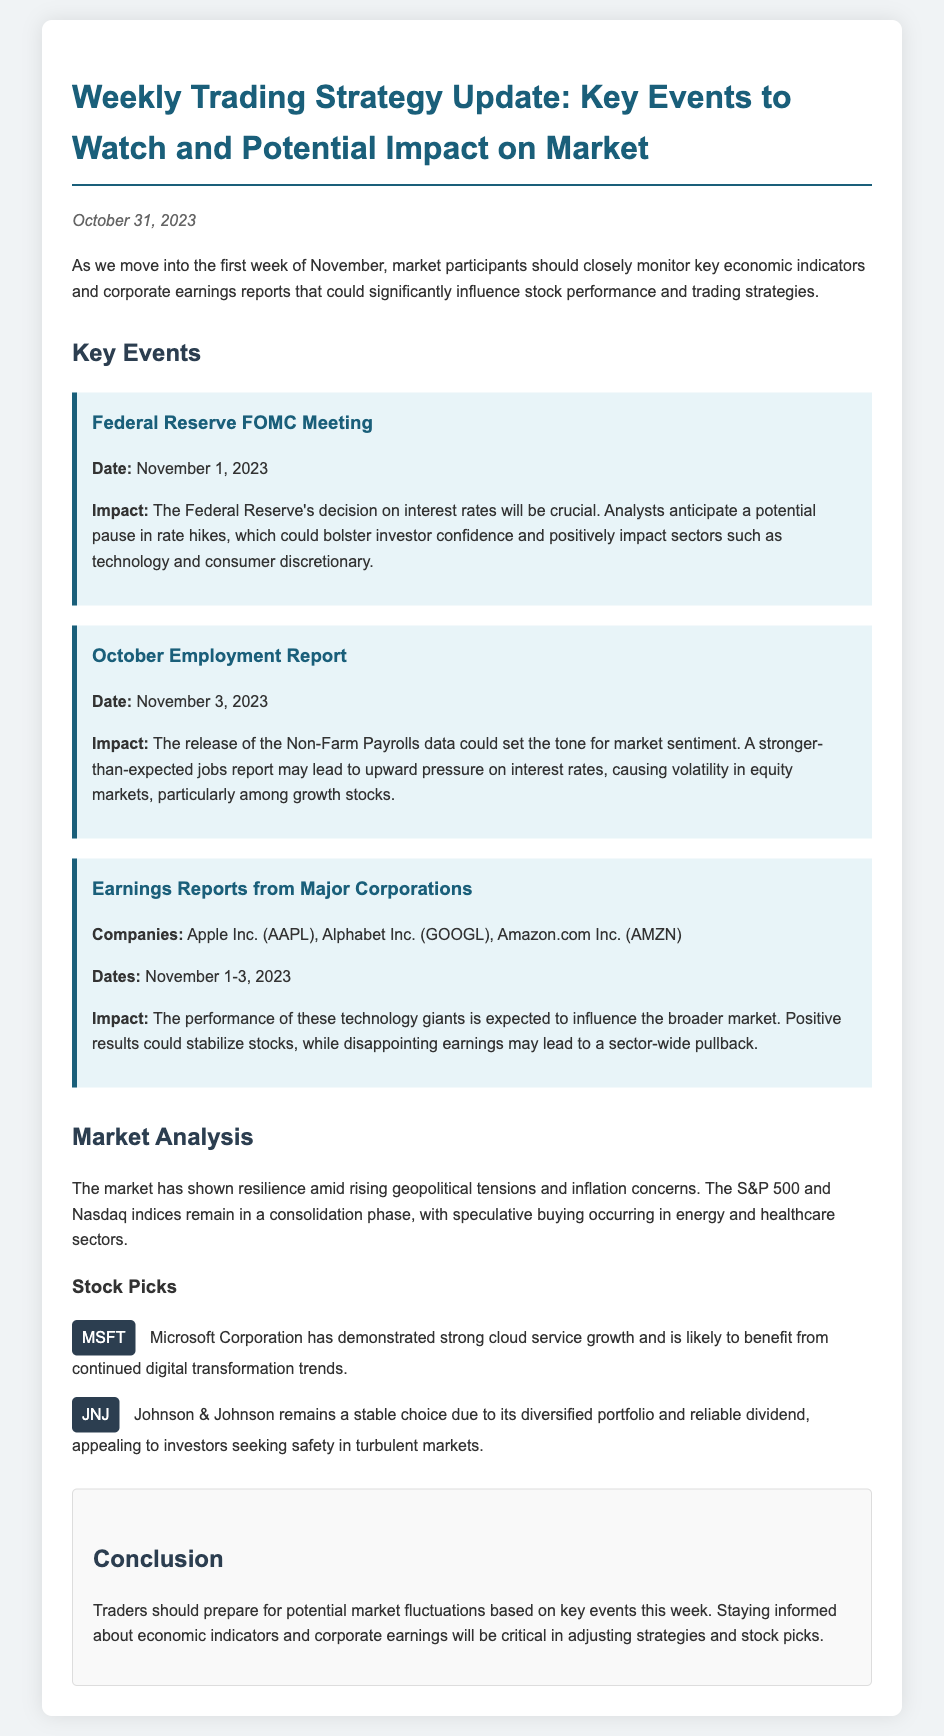What is the date of the Federal Reserve FOMC Meeting? The date of the Federal Reserve FOMC Meeting is mentioned in the document as November 1, 2023.
Answer: November 1, 2023 What companies are reporting earnings this week? The memo lists Apple Inc., Alphabet Inc., and Amazon.com Inc. as the companies reporting earnings.
Answer: Apple Inc., Alphabet Inc., Amazon.com Inc What potential impact is expected from the October Employment Report? The memo indicates that a stronger-than-expected jobs report may lead to upward pressure on interest rates, affecting market sentiment and volatility.
Answer: Upward pressure on interest rates Which stock is identified as appealing for safety? Johnson & Johnson is noted in the memo as a choice due to its diversified portfolio and reliable dividend.
Answer: Johnson & Johnson What is the impact expectation of the Federal Reserve's interest rate decision? The document states that a potential pause in rate hikes could bolster investor confidence and positively impact certain sectors.
Answer: Bolster investor confidence What date is the October Employment Report scheduled for? The date of the October Employment Report is given as November 3, 2023.
Answer: November 3, 2023 What sentiment do the S&P 500 and Nasdaq indices currently reflect? The market analysis in the document describes the indices as being in a consolidation phase.
Answer: Consolidation phase What are the two sectors where speculative buying is occurring? The memo mentions energy and healthcare sectors as areas of speculative buying.
Answer: Energy and healthcare 